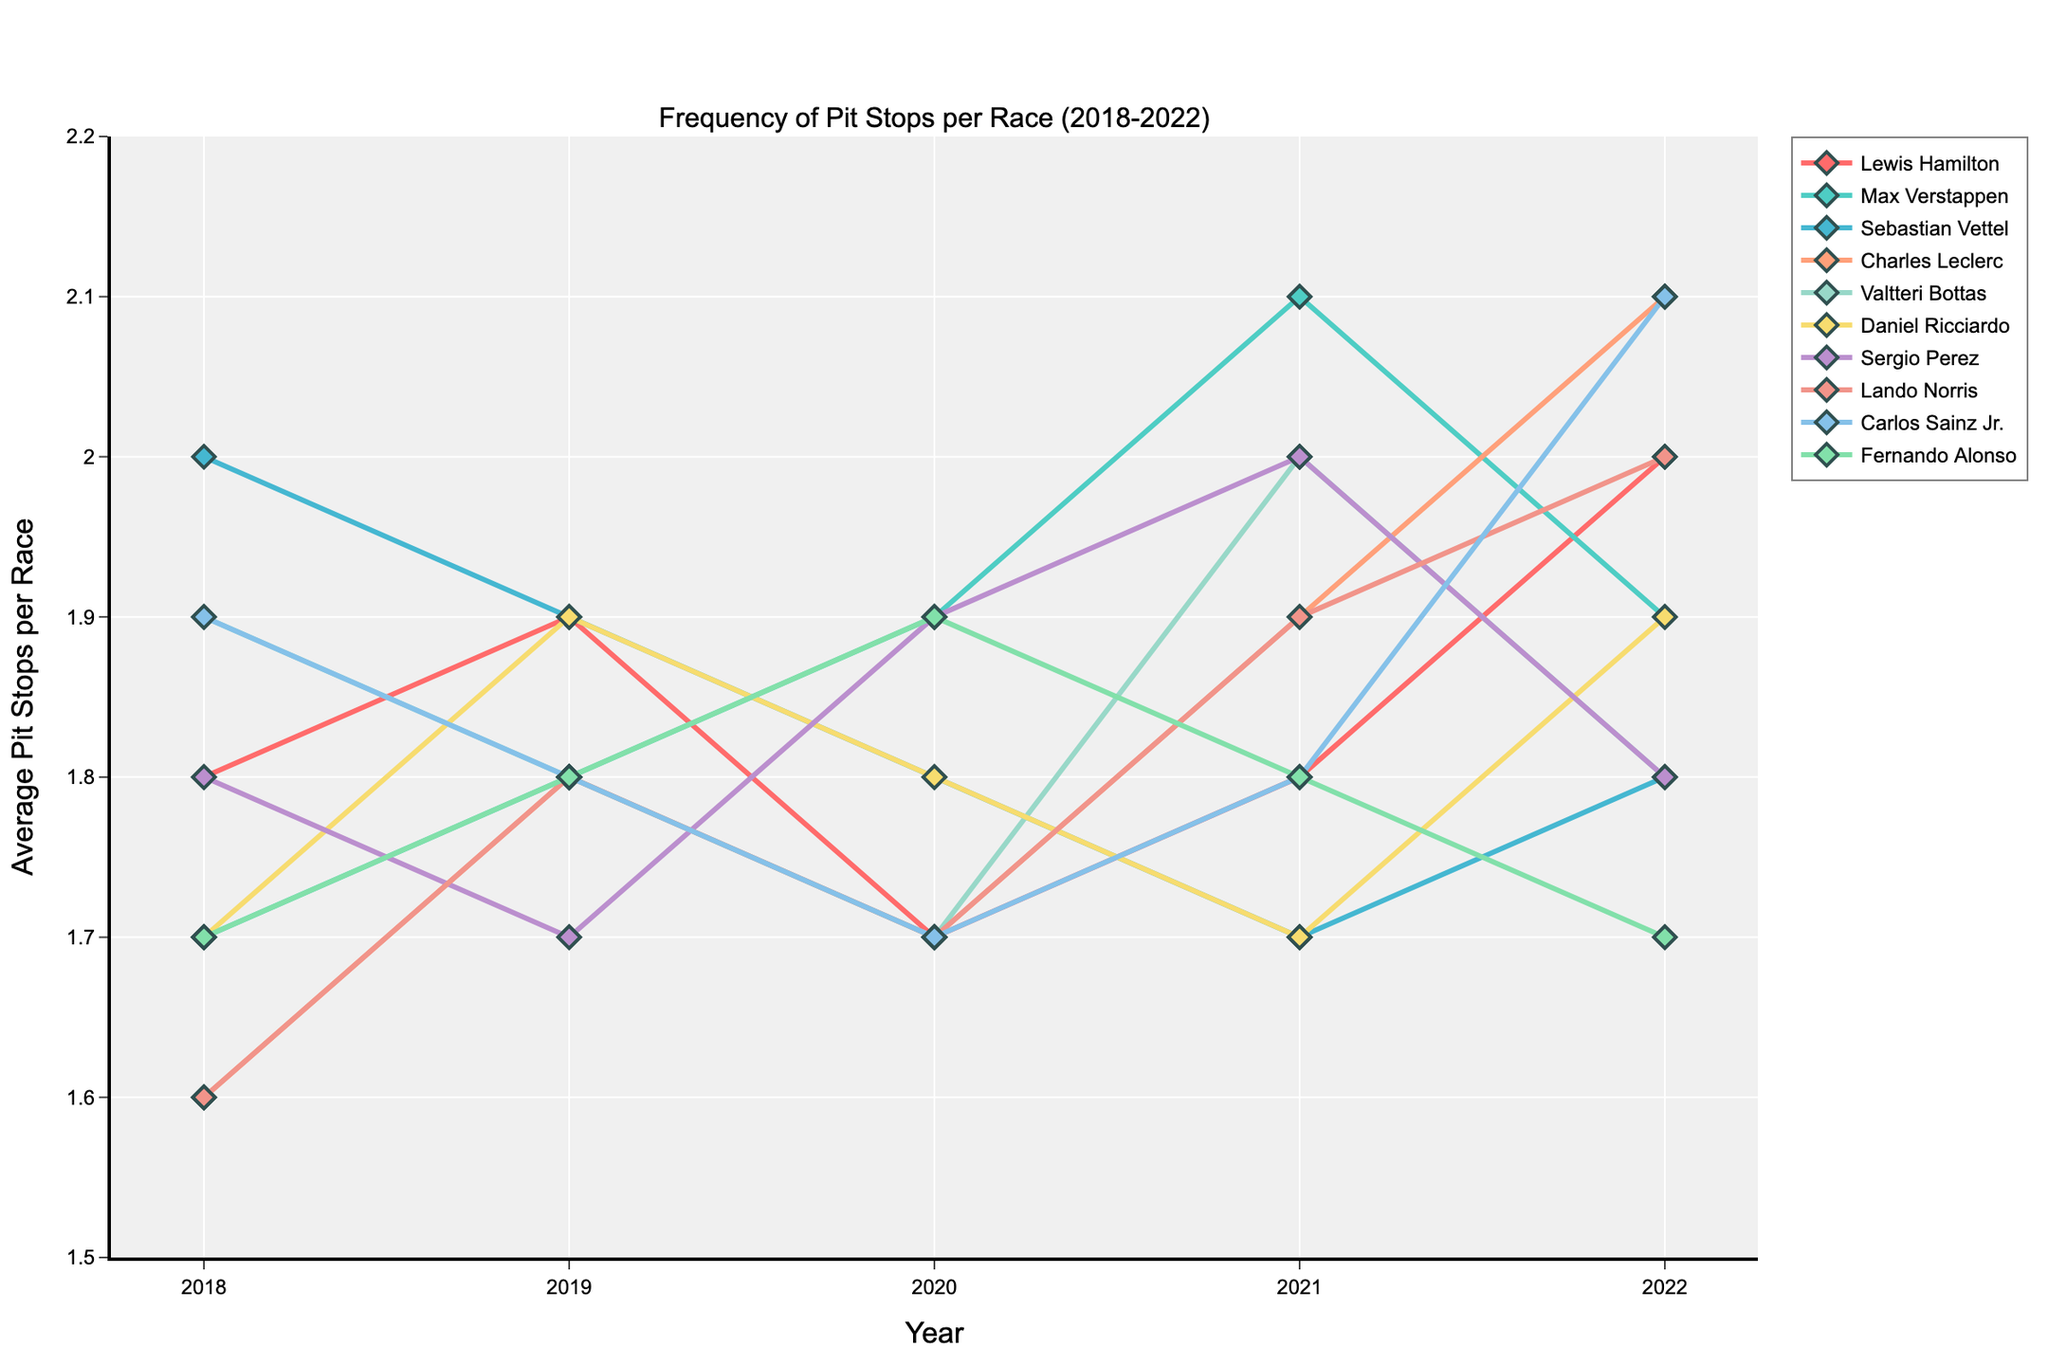What year did Carlos Sainz Jr. have the highest average number of pit stops per race? The line for Carlos Sainz Jr. shows the highest point in 2022 on the Y-axis.
Answer: 2022 Which driver had the lowest average number of pit stops per race in 2018? By comparing the 2018 data points for each driver, Charles Leclerc is the lowest at 1.6.
Answer: Charles Leclerc Who had a higher average number of pit stops per race in 2021, Daniel Ricciardo or Lando Norris? Compare the 2021 values for both drivers; Daniel Ricciardo had 1.7, while Lando Norris had 1.9.
Answer: Lando Norris What’s the average number of pit stops per race for Lewis Hamilton across all the years shown in the figure? Sum the values for Lewis Hamilton: 1.8 + 1.9 + 1.7 + 1.8 + 2.0 = 9.2, then divide by 5 years.
Answer: 1.84 Which driver had a decreasing trend in the average number of pit stops per race from 2018 to 2020? For a decreasing trend from 2018 to 2020, the values should sequentially decrease. Sebastian Vettel: 2.0, 1.9, 1.8.
Answer: Sebastian Vettel Among all the drivers, who had the highest average number of pit stops per race in any single year? Find the highest single value in the data set; Charles Leclerc in 2022 has 2.1.
Answer: Charles Leclerc Did Max Verstappen have a consistent increasing trend in average pit stops per race from 2018 to 2021? Check each year's value for an increase: 2018: 1.7, 2019: 1.8, 2020: 1.9, 2021: 2.1, all values increase over time.
Answer: Yes Comparing the colors of the lines, which driver's data is represented by the color red? The figure indicates which driver corresponds to which color, Lewis Hamilton is represented in red.
Answer: Lewis Hamilton 